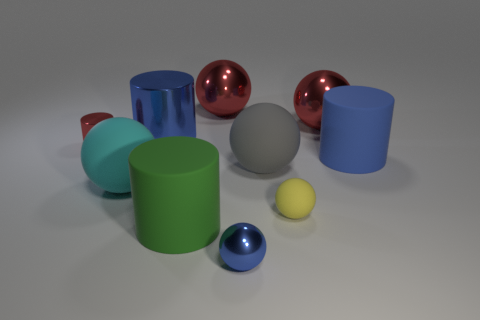There is a large metallic cylinder; is its color the same as the tiny object that is in front of the yellow matte ball?
Your answer should be compact. Yes. Is the color of the big cylinder that is behind the red cylinder the same as the small metallic ball?
Provide a short and direct response. Yes. There is a ball that is the same color as the large metal cylinder; what size is it?
Give a very brief answer. Small. Does the small metallic sphere have the same color as the big shiny cylinder?
Provide a short and direct response. Yes. Are there any small spheres of the same color as the big metal cylinder?
Give a very brief answer. Yes. Is there another matte object that has the same shape as the large blue rubber thing?
Offer a very short reply. Yes. What shape is the metal thing that is the same color as the large metal cylinder?
Give a very brief answer. Sphere. There is a big cylinder in front of the large blue cylinder that is to the right of the green cylinder; are there any spheres on the right side of it?
Keep it short and to the point. Yes. There is a red object that is the same size as the yellow sphere; what is its shape?
Keep it short and to the point. Cylinder. There is a tiny metallic object that is the same shape as the large blue matte object; what is its color?
Offer a very short reply. Red. 